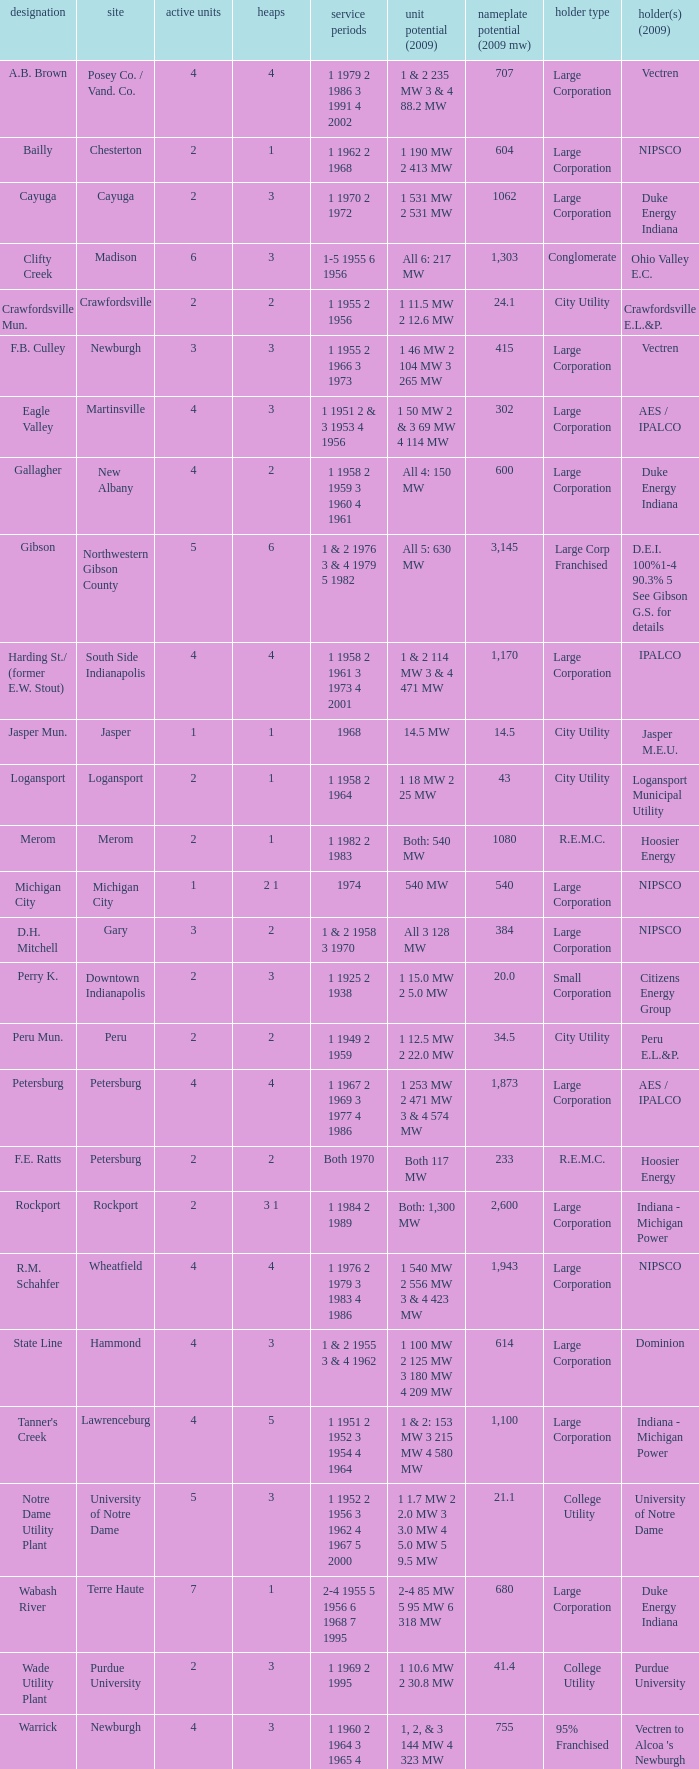Name the stacks for 1 1969 2 1995 3.0. 